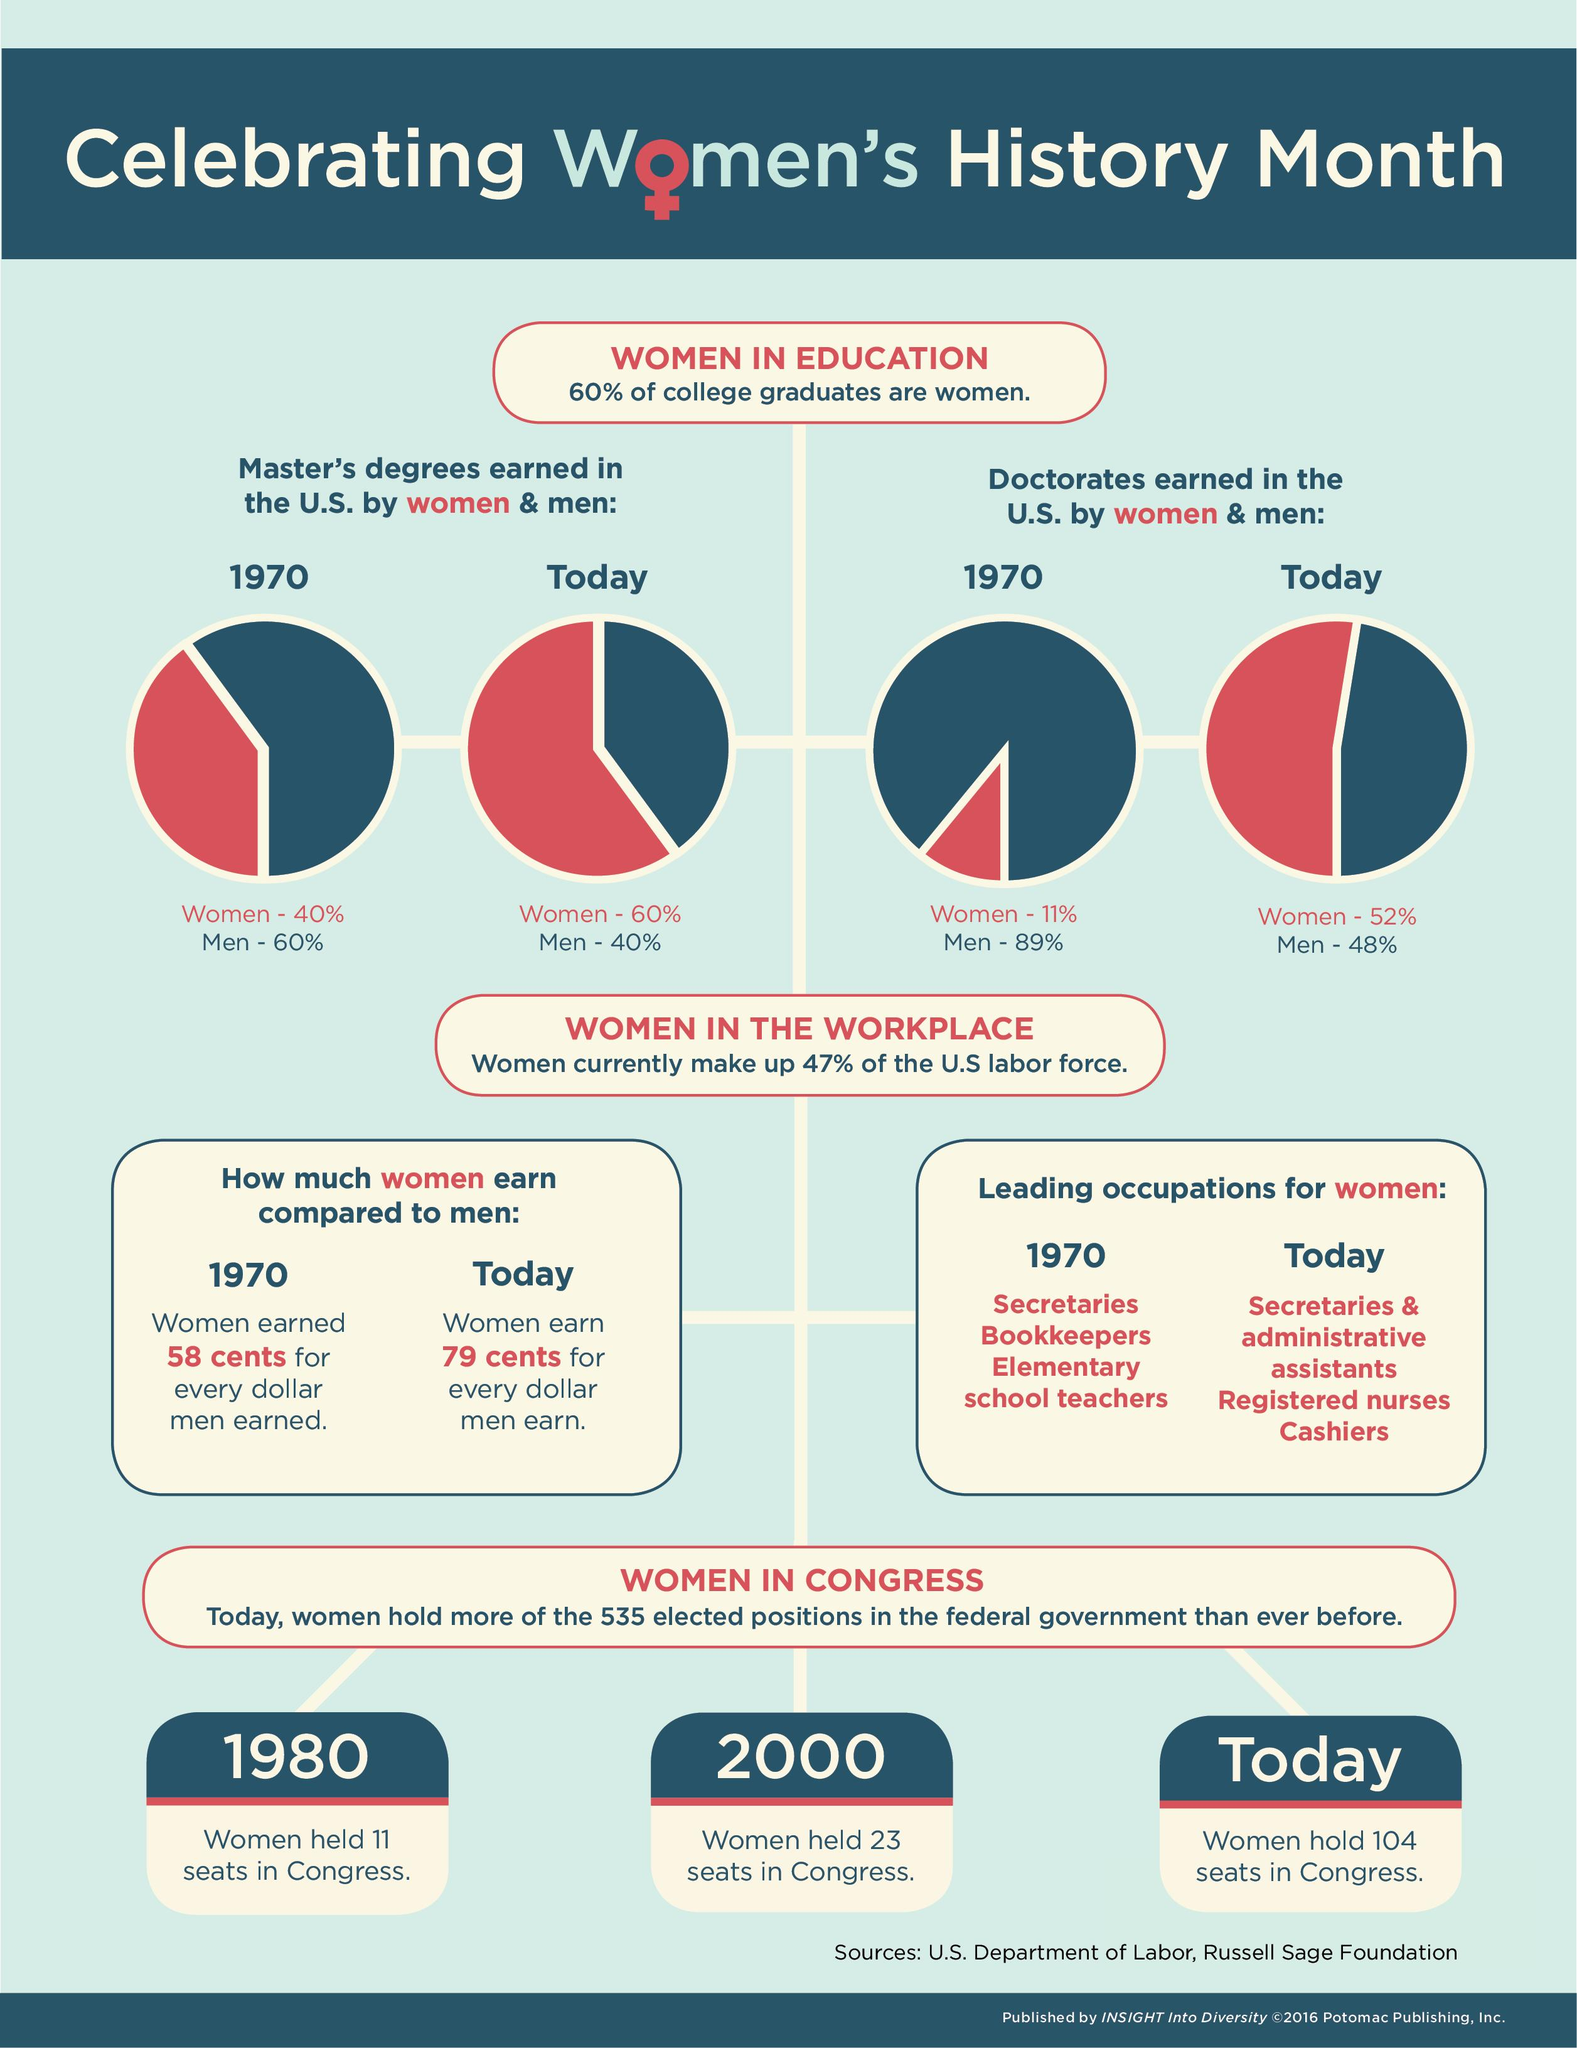Draw attention to some important aspects in this diagram. As of today, men earning doctorates in the US have experienced a reduction of 41% compared to the percentage in 1970. In the United States, the percentage of women earning master's degrees has increased by approximately 20% from 1970 to today. 